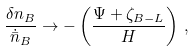Convert formula to latex. <formula><loc_0><loc_0><loc_500><loc_500>\frac { \delta n _ { B } } { \dot { \bar { n } } _ { B } } \rightarrow - \left ( \frac { \Psi + \zeta _ { B - L } } { H } \right ) \, ,</formula> 